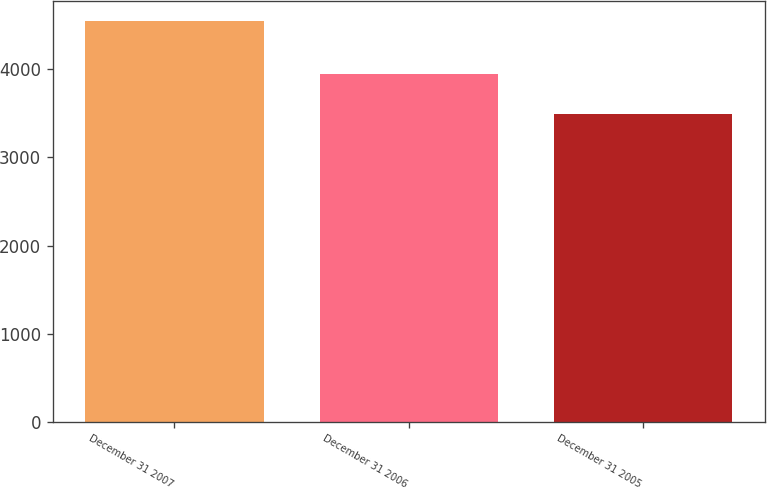Convert chart to OTSL. <chart><loc_0><loc_0><loc_500><loc_500><bar_chart><fcel>December 31 2007<fcel>December 31 2006<fcel>December 31 2005<nl><fcel>4544.2<fcel>3948.6<fcel>3493.8<nl></chart> 